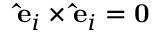Convert formula to latex. <formula><loc_0><loc_0><loc_500><loc_500>\hat { e } _ { i } \times \hat { e } _ { i } = 0</formula> 